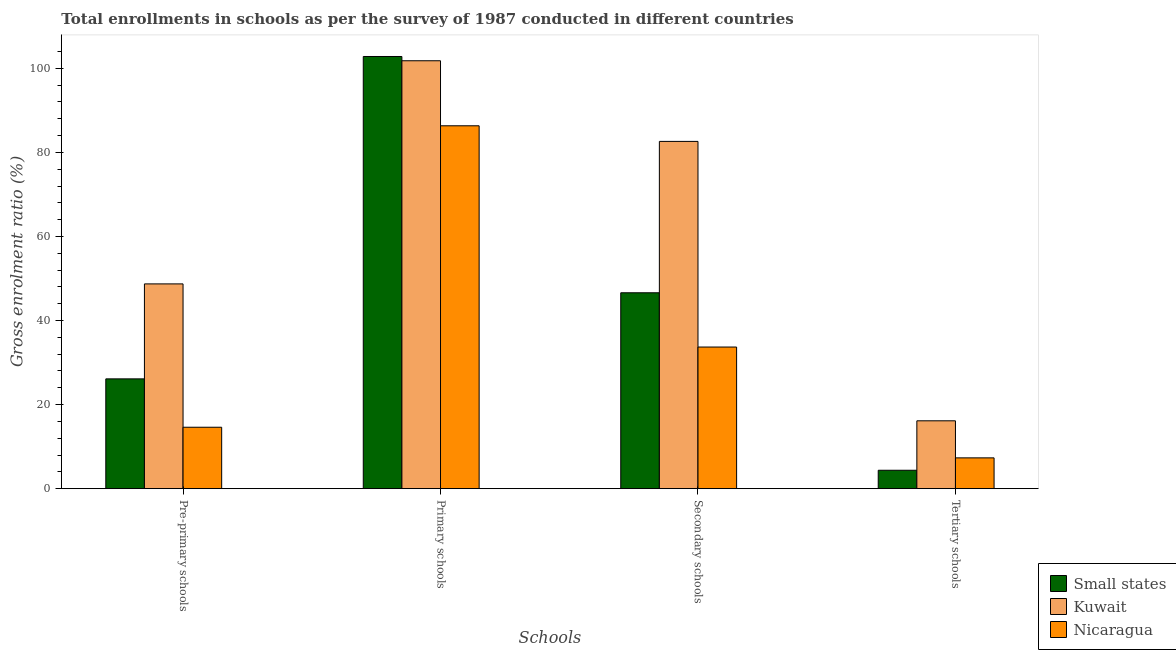How many different coloured bars are there?
Keep it short and to the point. 3. Are the number of bars on each tick of the X-axis equal?
Offer a terse response. Yes. How many bars are there on the 3rd tick from the left?
Keep it short and to the point. 3. How many bars are there on the 1st tick from the right?
Your answer should be very brief. 3. What is the label of the 2nd group of bars from the left?
Your response must be concise. Primary schools. What is the gross enrolment ratio in pre-primary schools in Small states?
Your answer should be compact. 26.12. Across all countries, what is the maximum gross enrolment ratio in secondary schools?
Make the answer very short. 82.61. Across all countries, what is the minimum gross enrolment ratio in pre-primary schools?
Provide a succinct answer. 14.61. In which country was the gross enrolment ratio in primary schools maximum?
Make the answer very short. Small states. In which country was the gross enrolment ratio in tertiary schools minimum?
Offer a very short reply. Small states. What is the total gross enrolment ratio in primary schools in the graph?
Your response must be concise. 290.93. What is the difference between the gross enrolment ratio in secondary schools in Nicaragua and that in Kuwait?
Your answer should be very brief. -48.92. What is the difference between the gross enrolment ratio in primary schools in Nicaragua and the gross enrolment ratio in tertiary schools in Kuwait?
Make the answer very short. 70.18. What is the average gross enrolment ratio in secondary schools per country?
Provide a succinct answer. 54.3. What is the difference between the gross enrolment ratio in pre-primary schools and gross enrolment ratio in tertiary schools in Nicaragua?
Provide a short and direct response. 7.29. What is the ratio of the gross enrolment ratio in primary schools in Small states to that in Kuwait?
Ensure brevity in your answer.  1.01. Is the gross enrolment ratio in pre-primary schools in Nicaragua less than that in Small states?
Offer a terse response. Yes. What is the difference between the highest and the second highest gross enrolment ratio in tertiary schools?
Offer a terse response. 8.82. What is the difference between the highest and the lowest gross enrolment ratio in secondary schools?
Ensure brevity in your answer.  48.92. In how many countries, is the gross enrolment ratio in primary schools greater than the average gross enrolment ratio in primary schools taken over all countries?
Ensure brevity in your answer.  2. Is the sum of the gross enrolment ratio in tertiary schools in Kuwait and Small states greater than the maximum gross enrolment ratio in secondary schools across all countries?
Ensure brevity in your answer.  No. What does the 2nd bar from the left in Secondary schools represents?
Your response must be concise. Kuwait. What does the 1st bar from the right in Pre-primary schools represents?
Offer a terse response. Nicaragua. Is it the case that in every country, the sum of the gross enrolment ratio in pre-primary schools and gross enrolment ratio in primary schools is greater than the gross enrolment ratio in secondary schools?
Keep it short and to the point. Yes. How many bars are there?
Keep it short and to the point. 12. Are the values on the major ticks of Y-axis written in scientific E-notation?
Ensure brevity in your answer.  No. Does the graph contain any zero values?
Give a very brief answer. No. Does the graph contain grids?
Your response must be concise. No. Where does the legend appear in the graph?
Offer a very short reply. Bottom right. How many legend labels are there?
Provide a succinct answer. 3. How are the legend labels stacked?
Provide a short and direct response. Vertical. What is the title of the graph?
Make the answer very short. Total enrollments in schools as per the survey of 1987 conducted in different countries. What is the label or title of the X-axis?
Offer a terse response. Schools. What is the label or title of the Y-axis?
Provide a succinct answer. Gross enrolment ratio (%). What is the Gross enrolment ratio (%) of Small states in Pre-primary schools?
Give a very brief answer. 26.12. What is the Gross enrolment ratio (%) of Kuwait in Pre-primary schools?
Keep it short and to the point. 48.71. What is the Gross enrolment ratio (%) in Nicaragua in Pre-primary schools?
Provide a succinct answer. 14.61. What is the Gross enrolment ratio (%) of Small states in Primary schools?
Keep it short and to the point. 102.81. What is the Gross enrolment ratio (%) of Kuwait in Primary schools?
Your answer should be very brief. 101.79. What is the Gross enrolment ratio (%) in Nicaragua in Primary schools?
Offer a very short reply. 86.32. What is the Gross enrolment ratio (%) in Small states in Secondary schools?
Offer a very short reply. 46.6. What is the Gross enrolment ratio (%) in Kuwait in Secondary schools?
Offer a very short reply. 82.61. What is the Gross enrolment ratio (%) in Nicaragua in Secondary schools?
Your answer should be compact. 33.69. What is the Gross enrolment ratio (%) in Small states in Tertiary schools?
Your answer should be compact. 4.38. What is the Gross enrolment ratio (%) in Kuwait in Tertiary schools?
Provide a short and direct response. 16.14. What is the Gross enrolment ratio (%) of Nicaragua in Tertiary schools?
Give a very brief answer. 7.33. Across all Schools, what is the maximum Gross enrolment ratio (%) in Small states?
Your answer should be very brief. 102.81. Across all Schools, what is the maximum Gross enrolment ratio (%) in Kuwait?
Your response must be concise. 101.79. Across all Schools, what is the maximum Gross enrolment ratio (%) of Nicaragua?
Offer a terse response. 86.32. Across all Schools, what is the minimum Gross enrolment ratio (%) in Small states?
Your answer should be compact. 4.38. Across all Schools, what is the minimum Gross enrolment ratio (%) in Kuwait?
Give a very brief answer. 16.14. Across all Schools, what is the minimum Gross enrolment ratio (%) of Nicaragua?
Offer a very short reply. 7.33. What is the total Gross enrolment ratio (%) of Small states in the graph?
Keep it short and to the point. 179.91. What is the total Gross enrolment ratio (%) of Kuwait in the graph?
Your response must be concise. 249.26. What is the total Gross enrolment ratio (%) in Nicaragua in the graph?
Your response must be concise. 141.96. What is the difference between the Gross enrolment ratio (%) in Small states in Pre-primary schools and that in Primary schools?
Make the answer very short. -76.69. What is the difference between the Gross enrolment ratio (%) of Kuwait in Pre-primary schools and that in Primary schools?
Your response must be concise. -53.08. What is the difference between the Gross enrolment ratio (%) in Nicaragua in Pre-primary schools and that in Primary schools?
Your answer should be compact. -71.71. What is the difference between the Gross enrolment ratio (%) of Small states in Pre-primary schools and that in Secondary schools?
Your response must be concise. -20.48. What is the difference between the Gross enrolment ratio (%) in Kuwait in Pre-primary schools and that in Secondary schools?
Offer a terse response. -33.9. What is the difference between the Gross enrolment ratio (%) of Nicaragua in Pre-primary schools and that in Secondary schools?
Give a very brief answer. -19.08. What is the difference between the Gross enrolment ratio (%) in Small states in Pre-primary schools and that in Tertiary schools?
Offer a very short reply. 21.74. What is the difference between the Gross enrolment ratio (%) in Kuwait in Pre-primary schools and that in Tertiary schools?
Provide a short and direct response. 32.57. What is the difference between the Gross enrolment ratio (%) of Nicaragua in Pre-primary schools and that in Tertiary schools?
Make the answer very short. 7.29. What is the difference between the Gross enrolment ratio (%) in Small states in Primary schools and that in Secondary schools?
Provide a short and direct response. 56.21. What is the difference between the Gross enrolment ratio (%) in Kuwait in Primary schools and that in Secondary schools?
Make the answer very short. 19.18. What is the difference between the Gross enrolment ratio (%) in Nicaragua in Primary schools and that in Secondary schools?
Keep it short and to the point. 52.63. What is the difference between the Gross enrolment ratio (%) of Small states in Primary schools and that in Tertiary schools?
Your answer should be very brief. 98.43. What is the difference between the Gross enrolment ratio (%) of Kuwait in Primary schools and that in Tertiary schools?
Provide a succinct answer. 85.65. What is the difference between the Gross enrolment ratio (%) of Nicaragua in Primary schools and that in Tertiary schools?
Make the answer very short. 78.99. What is the difference between the Gross enrolment ratio (%) in Small states in Secondary schools and that in Tertiary schools?
Keep it short and to the point. 42.22. What is the difference between the Gross enrolment ratio (%) of Kuwait in Secondary schools and that in Tertiary schools?
Make the answer very short. 66.47. What is the difference between the Gross enrolment ratio (%) of Nicaragua in Secondary schools and that in Tertiary schools?
Give a very brief answer. 26.36. What is the difference between the Gross enrolment ratio (%) in Small states in Pre-primary schools and the Gross enrolment ratio (%) in Kuwait in Primary schools?
Give a very brief answer. -75.67. What is the difference between the Gross enrolment ratio (%) in Small states in Pre-primary schools and the Gross enrolment ratio (%) in Nicaragua in Primary schools?
Provide a succinct answer. -60.2. What is the difference between the Gross enrolment ratio (%) of Kuwait in Pre-primary schools and the Gross enrolment ratio (%) of Nicaragua in Primary schools?
Offer a very short reply. -37.61. What is the difference between the Gross enrolment ratio (%) of Small states in Pre-primary schools and the Gross enrolment ratio (%) of Kuwait in Secondary schools?
Keep it short and to the point. -56.49. What is the difference between the Gross enrolment ratio (%) of Small states in Pre-primary schools and the Gross enrolment ratio (%) of Nicaragua in Secondary schools?
Your answer should be very brief. -7.57. What is the difference between the Gross enrolment ratio (%) in Kuwait in Pre-primary schools and the Gross enrolment ratio (%) in Nicaragua in Secondary schools?
Provide a short and direct response. 15.02. What is the difference between the Gross enrolment ratio (%) in Small states in Pre-primary schools and the Gross enrolment ratio (%) in Kuwait in Tertiary schools?
Make the answer very short. 9.98. What is the difference between the Gross enrolment ratio (%) of Small states in Pre-primary schools and the Gross enrolment ratio (%) of Nicaragua in Tertiary schools?
Give a very brief answer. 18.79. What is the difference between the Gross enrolment ratio (%) of Kuwait in Pre-primary schools and the Gross enrolment ratio (%) of Nicaragua in Tertiary schools?
Provide a short and direct response. 41.39. What is the difference between the Gross enrolment ratio (%) of Small states in Primary schools and the Gross enrolment ratio (%) of Kuwait in Secondary schools?
Your answer should be very brief. 20.2. What is the difference between the Gross enrolment ratio (%) in Small states in Primary schools and the Gross enrolment ratio (%) in Nicaragua in Secondary schools?
Provide a succinct answer. 69.12. What is the difference between the Gross enrolment ratio (%) of Kuwait in Primary schools and the Gross enrolment ratio (%) of Nicaragua in Secondary schools?
Ensure brevity in your answer.  68.1. What is the difference between the Gross enrolment ratio (%) of Small states in Primary schools and the Gross enrolment ratio (%) of Kuwait in Tertiary schools?
Your answer should be compact. 86.67. What is the difference between the Gross enrolment ratio (%) in Small states in Primary schools and the Gross enrolment ratio (%) in Nicaragua in Tertiary schools?
Offer a very short reply. 95.48. What is the difference between the Gross enrolment ratio (%) in Kuwait in Primary schools and the Gross enrolment ratio (%) in Nicaragua in Tertiary schools?
Give a very brief answer. 94.46. What is the difference between the Gross enrolment ratio (%) of Small states in Secondary schools and the Gross enrolment ratio (%) of Kuwait in Tertiary schools?
Keep it short and to the point. 30.46. What is the difference between the Gross enrolment ratio (%) of Small states in Secondary schools and the Gross enrolment ratio (%) of Nicaragua in Tertiary schools?
Your answer should be very brief. 39.27. What is the difference between the Gross enrolment ratio (%) of Kuwait in Secondary schools and the Gross enrolment ratio (%) of Nicaragua in Tertiary schools?
Provide a succinct answer. 75.28. What is the average Gross enrolment ratio (%) in Small states per Schools?
Ensure brevity in your answer.  44.98. What is the average Gross enrolment ratio (%) in Kuwait per Schools?
Provide a short and direct response. 62.32. What is the average Gross enrolment ratio (%) of Nicaragua per Schools?
Give a very brief answer. 35.49. What is the difference between the Gross enrolment ratio (%) of Small states and Gross enrolment ratio (%) of Kuwait in Pre-primary schools?
Provide a succinct answer. -22.59. What is the difference between the Gross enrolment ratio (%) of Small states and Gross enrolment ratio (%) of Nicaragua in Pre-primary schools?
Offer a terse response. 11.51. What is the difference between the Gross enrolment ratio (%) in Kuwait and Gross enrolment ratio (%) in Nicaragua in Pre-primary schools?
Give a very brief answer. 34.1. What is the difference between the Gross enrolment ratio (%) in Small states and Gross enrolment ratio (%) in Kuwait in Primary schools?
Ensure brevity in your answer.  1.02. What is the difference between the Gross enrolment ratio (%) of Small states and Gross enrolment ratio (%) of Nicaragua in Primary schools?
Offer a terse response. 16.49. What is the difference between the Gross enrolment ratio (%) of Kuwait and Gross enrolment ratio (%) of Nicaragua in Primary schools?
Make the answer very short. 15.47. What is the difference between the Gross enrolment ratio (%) in Small states and Gross enrolment ratio (%) in Kuwait in Secondary schools?
Your answer should be very brief. -36.01. What is the difference between the Gross enrolment ratio (%) of Small states and Gross enrolment ratio (%) of Nicaragua in Secondary schools?
Your answer should be compact. 12.91. What is the difference between the Gross enrolment ratio (%) of Kuwait and Gross enrolment ratio (%) of Nicaragua in Secondary schools?
Your answer should be very brief. 48.92. What is the difference between the Gross enrolment ratio (%) in Small states and Gross enrolment ratio (%) in Kuwait in Tertiary schools?
Ensure brevity in your answer.  -11.76. What is the difference between the Gross enrolment ratio (%) in Small states and Gross enrolment ratio (%) in Nicaragua in Tertiary schools?
Offer a very short reply. -2.95. What is the difference between the Gross enrolment ratio (%) in Kuwait and Gross enrolment ratio (%) in Nicaragua in Tertiary schools?
Keep it short and to the point. 8.82. What is the ratio of the Gross enrolment ratio (%) in Small states in Pre-primary schools to that in Primary schools?
Give a very brief answer. 0.25. What is the ratio of the Gross enrolment ratio (%) of Kuwait in Pre-primary schools to that in Primary schools?
Ensure brevity in your answer.  0.48. What is the ratio of the Gross enrolment ratio (%) in Nicaragua in Pre-primary schools to that in Primary schools?
Provide a short and direct response. 0.17. What is the ratio of the Gross enrolment ratio (%) of Small states in Pre-primary schools to that in Secondary schools?
Offer a very short reply. 0.56. What is the ratio of the Gross enrolment ratio (%) of Kuwait in Pre-primary schools to that in Secondary schools?
Keep it short and to the point. 0.59. What is the ratio of the Gross enrolment ratio (%) of Nicaragua in Pre-primary schools to that in Secondary schools?
Make the answer very short. 0.43. What is the ratio of the Gross enrolment ratio (%) of Small states in Pre-primary schools to that in Tertiary schools?
Your answer should be compact. 5.96. What is the ratio of the Gross enrolment ratio (%) in Kuwait in Pre-primary schools to that in Tertiary schools?
Give a very brief answer. 3.02. What is the ratio of the Gross enrolment ratio (%) of Nicaragua in Pre-primary schools to that in Tertiary schools?
Your response must be concise. 1.99. What is the ratio of the Gross enrolment ratio (%) in Small states in Primary schools to that in Secondary schools?
Your response must be concise. 2.21. What is the ratio of the Gross enrolment ratio (%) of Kuwait in Primary schools to that in Secondary schools?
Provide a short and direct response. 1.23. What is the ratio of the Gross enrolment ratio (%) of Nicaragua in Primary schools to that in Secondary schools?
Give a very brief answer. 2.56. What is the ratio of the Gross enrolment ratio (%) in Small states in Primary schools to that in Tertiary schools?
Provide a succinct answer. 23.46. What is the ratio of the Gross enrolment ratio (%) in Kuwait in Primary schools to that in Tertiary schools?
Provide a short and direct response. 6.31. What is the ratio of the Gross enrolment ratio (%) in Nicaragua in Primary schools to that in Tertiary schools?
Provide a short and direct response. 11.78. What is the ratio of the Gross enrolment ratio (%) of Small states in Secondary schools to that in Tertiary schools?
Provide a short and direct response. 10.63. What is the ratio of the Gross enrolment ratio (%) of Kuwait in Secondary schools to that in Tertiary schools?
Your answer should be compact. 5.12. What is the ratio of the Gross enrolment ratio (%) of Nicaragua in Secondary schools to that in Tertiary schools?
Ensure brevity in your answer.  4.6. What is the difference between the highest and the second highest Gross enrolment ratio (%) in Small states?
Give a very brief answer. 56.21. What is the difference between the highest and the second highest Gross enrolment ratio (%) in Kuwait?
Give a very brief answer. 19.18. What is the difference between the highest and the second highest Gross enrolment ratio (%) in Nicaragua?
Provide a short and direct response. 52.63. What is the difference between the highest and the lowest Gross enrolment ratio (%) in Small states?
Offer a very short reply. 98.43. What is the difference between the highest and the lowest Gross enrolment ratio (%) in Kuwait?
Provide a short and direct response. 85.65. What is the difference between the highest and the lowest Gross enrolment ratio (%) of Nicaragua?
Make the answer very short. 78.99. 